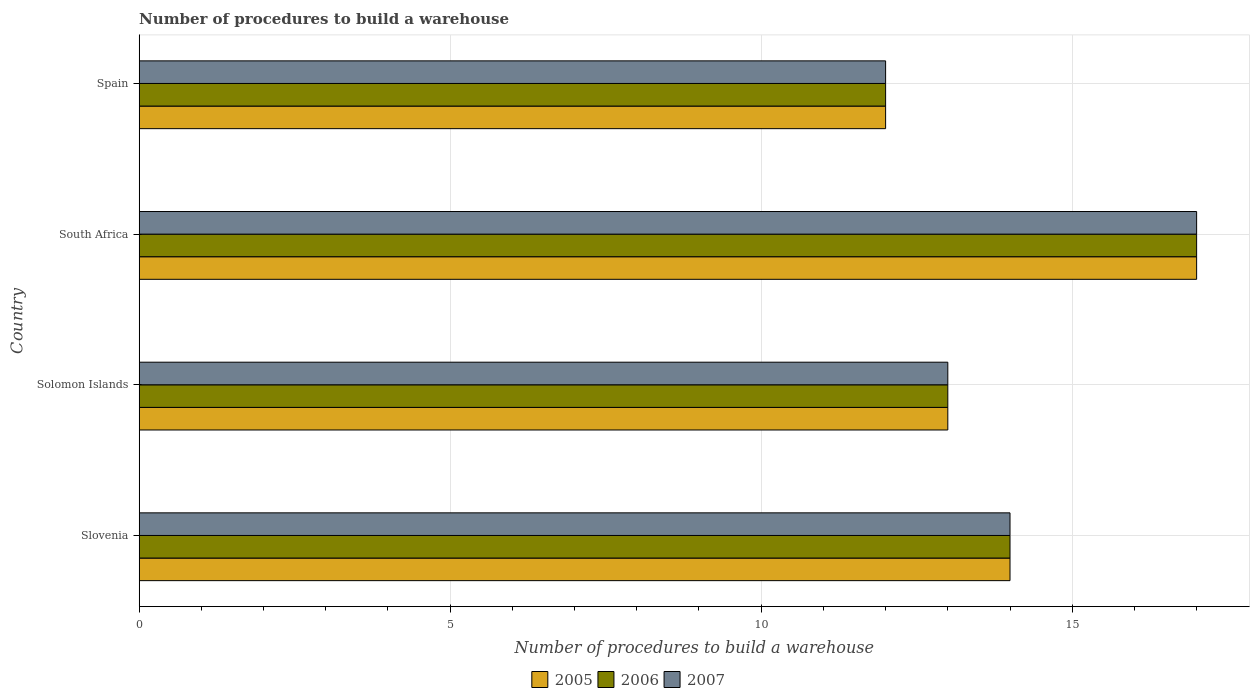How many groups of bars are there?
Offer a terse response. 4. Are the number of bars per tick equal to the number of legend labels?
Ensure brevity in your answer.  Yes. How many bars are there on the 1st tick from the bottom?
Keep it short and to the point. 3. What is the label of the 4th group of bars from the top?
Provide a short and direct response. Slovenia. What is the number of procedures to build a warehouse in in 2007 in Spain?
Your answer should be very brief. 12. In which country was the number of procedures to build a warehouse in in 2006 maximum?
Your answer should be very brief. South Africa. In which country was the number of procedures to build a warehouse in in 2005 minimum?
Keep it short and to the point. Spain. What is the difference between the number of procedures to build a warehouse in in 2006 in Solomon Islands and that in Spain?
Keep it short and to the point. 1. What is the difference between the number of procedures to build a warehouse in in 2006 in Solomon Islands and the number of procedures to build a warehouse in in 2007 in South Africa?
Your response must be concise. -4. What is the average number of procedures to build a warehouse in in 2006 per country?
Make the answer very short. 14. What is the difference between the number of procedures to build a warehouse in in 2006 and number of procedures to build a warehouse in in 2005 in South Africa?
Give a very brief answer. 0. What is the ratio of the number of procedures to build a warehouse in in 2006 in Slovenia to that in Spain?
Offer a very short reply. 1.17. Is the difference between the number of procedures to build a warehouse in in 2006 in South Africa and Spain greater than the difference between the number of procedures to build a warehouse in in 2005 in South Africa and Spain?
Offer a very short reply. No. What is the difference between the highest and the lowest number of procedures to build a warehouse in in 2007?
Your response must be concise. 5. Is the sum of the number of procedures to build a warehouse in in 2006 in South Africa and Spain greater than the maximum number of procedures to build a warehouse in in 2005 across all countries?
Ensure brevity in your answer.  Yes. Are all the bars in the graph horizontal?
Your answer should be compact. Yes. How many countries are there in the graph?
Offer a very short reply. 4. What is the difference between two consecutive major ticks on the X-axis?
Keep it short and to the point. 5. Does the graph contain any zero values?
Your answer should be compact. No. What is the title of the graph?
Your response must be concise. Number of procedures to build a warehouse. Does "1980" appear as one of the legend labels in the graph?
Ensure brevity in your answer.  No. What is the label or title of the X-axis?
Offer a very short reply. Number of procedures to build a warehouse. What is the Number of procedures to build a warehouse in 2005 in Slovenia?
Ensure brevity in your answer.  14. What is the Number of procedures to build a warehouse of 2006 in Slovenia?
Your answer should be very brief. 14. What is the Number of procedures to build a warehouse in 2007 in Slovenia?
Offer a very short reply. 14. What is the Number of procedures to build a warehouse in 2006 in South Africa?
Your answer should be very brief. 17. What is the Number of procedures to build a warehouse of 2007 in South Africa?
Keep it short and to the point. 17. What is the Number of procedures to build a warehouse in 2005 in Spain?
Provide a succinct answer. 12. What is the Number of procedures to build a warehouse in 2006 in Spain?
Ensure brevity in your answer.  12. Across all countries, what is the maximum Number of procedures to build a warehouse of 2005?
Offer a terse response. 17. Across all countries, what is the minimum Number of procedures to build a warehouse of 2007?
Provide a short and direct response. 12. What is the total Number of procedures to build a warehouse of 2007 in the graph?
Offer a terse response. 56. What is the difference between the Number of procedures to build a warehouse in 2005 in Slovenia and that in Solomon Islands?
Offer a terse response. 1. What is the difference between the Number of procedures to build a warehouse in 2007 in Slovenia and that in South Africa?
Provide a succinct answer. -3. What is the difference between the Number of procedures to build a warehouse in 2006 in Slovenia and that in Spain?
Your answer should be very brief. 2. What is the difference between the Number of procedures to build a warehouse in 2005 in Solomon Islands and that in South Africa?
Your answer should be compact. -4. What is the difference between the Number of procedures to build a warehouse of 2006 in Solomon Islands and that in South Africa?
Your answer should be compact. -4. What is the difference between the Number of procedures to build a warehouse of 2005 in Slovenia and the Number of procedures to build a warehouse of 2006 in Solomon Islands?
Provide a short and direct response. 1. What is the difference between the Number of procedures to build a warehouse in 2005 in Slovenia and the Number of procedures to build a warehouse in 2007 in Solomon Islands?
Provide a short and direct response. 1. What is the difference between the Number of procedures to build a warehouse of 2006 in Slovenia and the Number of procedures to build a warehouse of 2007 in Solomon Islands?
Make the answer very short. 1. What is the difference between the Number of procedures to build a warehouse of 2005 in Slovenia and the Number of procedures to build a warehouse of 2006 in South Africa?
Offer a very short reply. -3. What is the difference between the Number of procedures to build a warehouse of 2006 in Slovenia and the Number of procedures to build a warehouse of 2007 in South Africa?
Keep it short and to the point. -3. What is the difference between the Number of procedures to build a warehouse of 2005 in Slovenia and the Number of procedures to build a warehouse of 2006 in Spain?
Ensure brevity in your answer.  2. What is the difference between the Number of procedures to build a warehouse of 2005 in Slovenia and the Number of procedures to build a warehouse of 2007 in Spain?
Provide a succinct answer. 2. What is the difference between the Number of procedures to build a warehouse of 2005 in Solomon Islands and the Number of procedures to build a warehouse of 2006 in South Africa?
Provide a short and direct response. -4. What is the difference between the Number of procedures to build a warehouse of 2005 in Solomon Islands and the Number of procedures to build a warehouse of 2006 in Spain?
Keep it short and to the point. 1. What is the difference between the Number of procedures to build a warehouse of 2006 in Solomon Islands and the Number of procedures to build a warehouse of 2007 in Spain?
Provide a short and direct response. 1. What is the difference between the Number of procedures to build a warehouse of 2005 in South Africa and the Number of procedures to build a warehouse of 2007 in Spain?
Provide a short and direct response. 5. What is the difference between the Number of procedures to build a warehouse in 2006 in South Africa and the Number of procedures to build a warehouse in 2007 in Spain?
Ensure brevity in your answer.  5. What is the average Number of procedures to build a warehouse in 2007 per country?
Your answer should be compact. 14. What is the difference between the Number of procedures to build a warehouse of 2005 and Number of procedures to build a warehouse of 2006 in Slovenia?
Your answer should be very brief. 0. What is the difference between the Number of procedures to build a warehouse in 2005 and Number of procedures to build a warehouse in 2007 in Solomon Islands?
Make the answer very short. 0. What is the difference between the Number of procedures to build a warehouse of 2005 and Number of procedures to build a warehouse of 2007 in South Africa?
Your response must be concise. 0. What is the difference between the Number of procedures to build a warehouse of 2006 and Number of procedures to build a warehouse of 2007 in South Africa?
Your answer should be compact. 0. What is the difference between the Number of procedures to build a warehouse in 2005 and Number of procedures to build a warehouse in 2007 in Spain?
Your response must be concise. 0. What is the difference between the Number of procedures to build a warehouse of 2006 and Number of procedures to build a warehouse of 2007 in Spain?
Ensure brevity in your answer.  0. What is the ratio of the Number of procedures to build a warehouse of 2006 in Slovenia to that in Solomon Islands?
Your answer should be compact. 1.08. What is the ratio of the Number of procedures to build a warehouse in 2007 in Slovenia to that in Solomon Islands?
Keep it short and to the point. 1.08. What is the ratio of the Number of procedures to build a warehouse in 2005 in Slovenia to that in South Africa?
Your answer should be very brief. 0.82. What is the ratio of the Number of procedures to build a warehouse of 2006 in Slovenia to that in South Africa?
Your answer should be very brief. 0.82. What is the ratio of the Number of procedures to build a warehouse in 2007 in Slovenia to that in South Africa?
Your response must be concise. 0.82. What is the ratio of the Number of procedures to build a warehouse of 2005 in Slovenia to that in Spain?
Ensure brevity in your answer.  1.17. What is the ratio of the Number of procedures to build a warehouse in 2005 in Solomon Islands to that in South Africa?
Offer a very short reply. 0.76. What is the ratio of the Number of procedures to build a warehouse in 2006 in Solomon Islands to that in South Africa?
Keep it short and to the point. 0.76. What is the ratio of the Number of procedures to build a warehouse of 2007 in Solomon Islands to that in South Africa?
Ensure brevity in your answer.  0.76. What is the ratio of the Number of procedures to build a warehouse of 2005 in Solomon Islands to that in Spain?
Give a very brief answer. 1.08. What is the ratio of the Number of procedures to build a warehouse of 2006 in Solomon Islands to that in Spain?
Provide a short and direct response. 1.08. What is the ratio of the Number of procedures to build a warehouse of 2005 in South Africa to that in Spain?
Your response must be concise. 1.42. What is the ratio of the Number of procedures to build a warehouse of 2006 in South Africa to that in Spain?
Your answer should be very brief. 1.42. What is the ratio of the Number of procedures to build a warehouse in 2007 in South Africa to that in Spain?
Ensure brevity in your answer.  1.42. What is the difference between the highest and the lowest Number of procedures to build a warehouse of 2005?
Provide a short and direct response. 5. What is the difference between the highest and the lowest Number of procedures to build a warehouse of 2007?
Your answer should be compact. 5. 